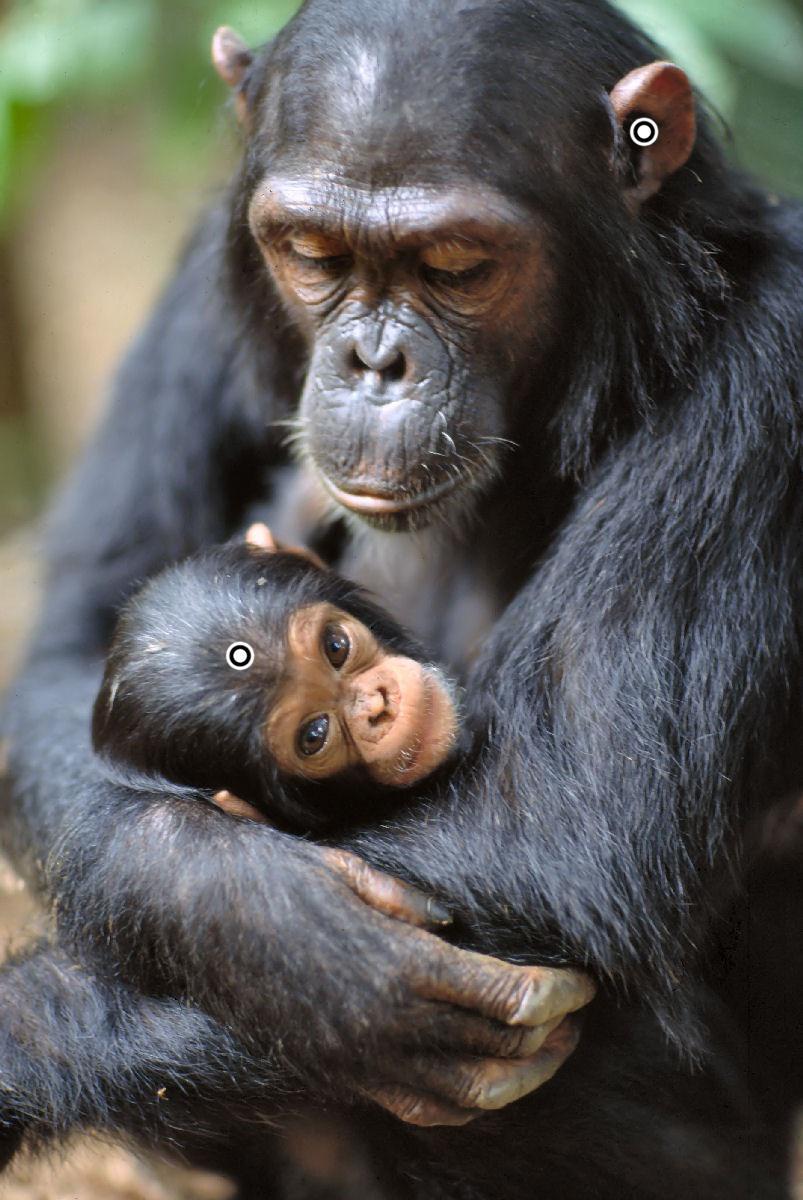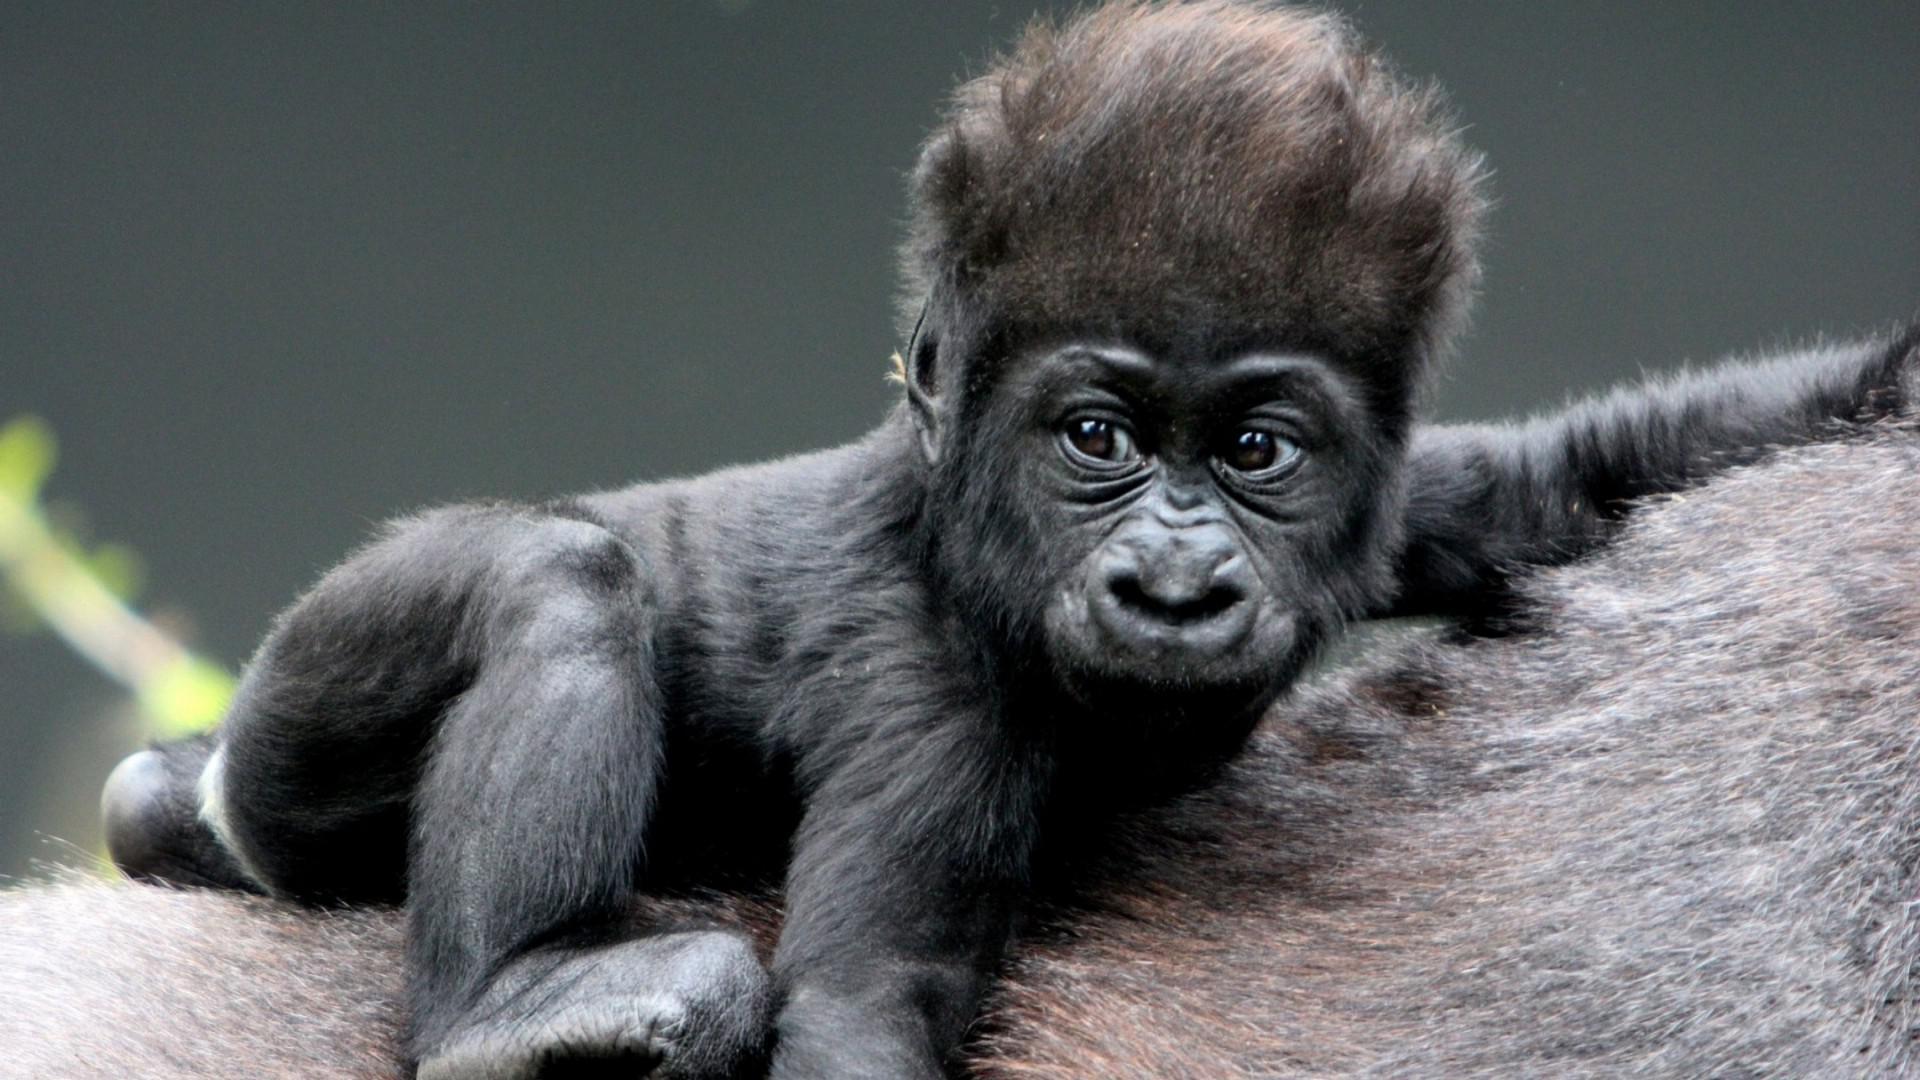The first image is the image on the left, the second image is the image on the right. Considering the images on both sides, is "A single young primate is lying down in the image on the right." valid? Answer yes or no. Yes. The first image is the image on the left, the second image is the image on the right. Evaluate the accuracy of this statement regarding the images: "An image shows an adult chimpanzee hugging a younger awake chimpanzee to its chest.". Is it true? Answer yes or no. Yes. 